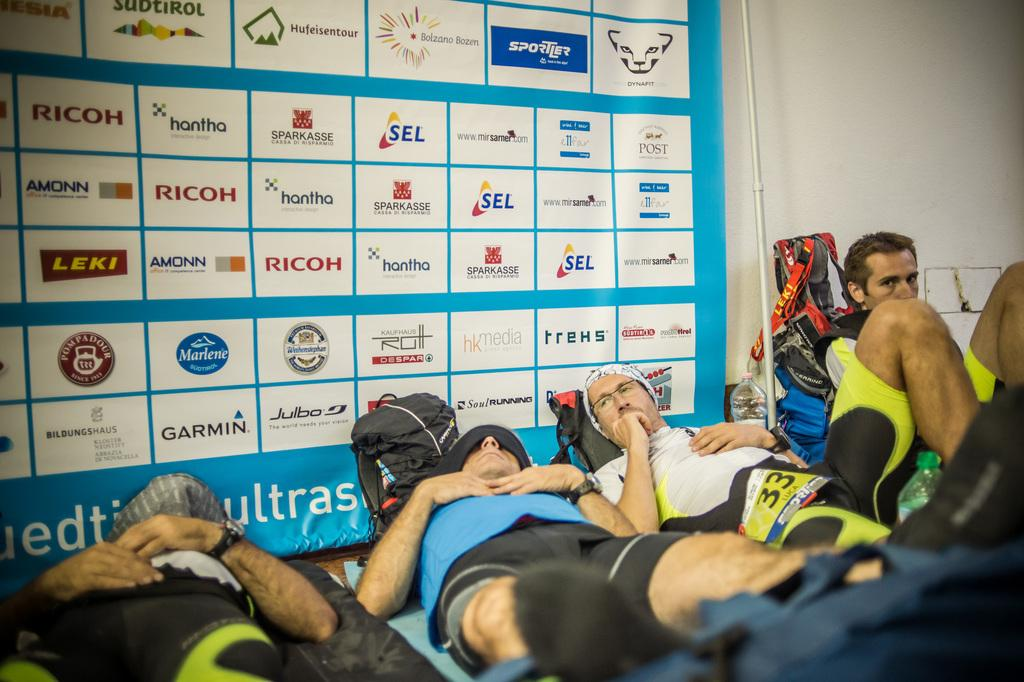What are the people in the image doing? The people in the image are lying and sitting on the floor. What objects can be seen in the image besides the people? There are bags, a rod, a bottle, and a banner with images and text in the background of the image. What type of grain is being used as a substance to control the behavior of the people in the image? There is no grain or substance mentioned in the image, and no behavior of the people is being controlled. 